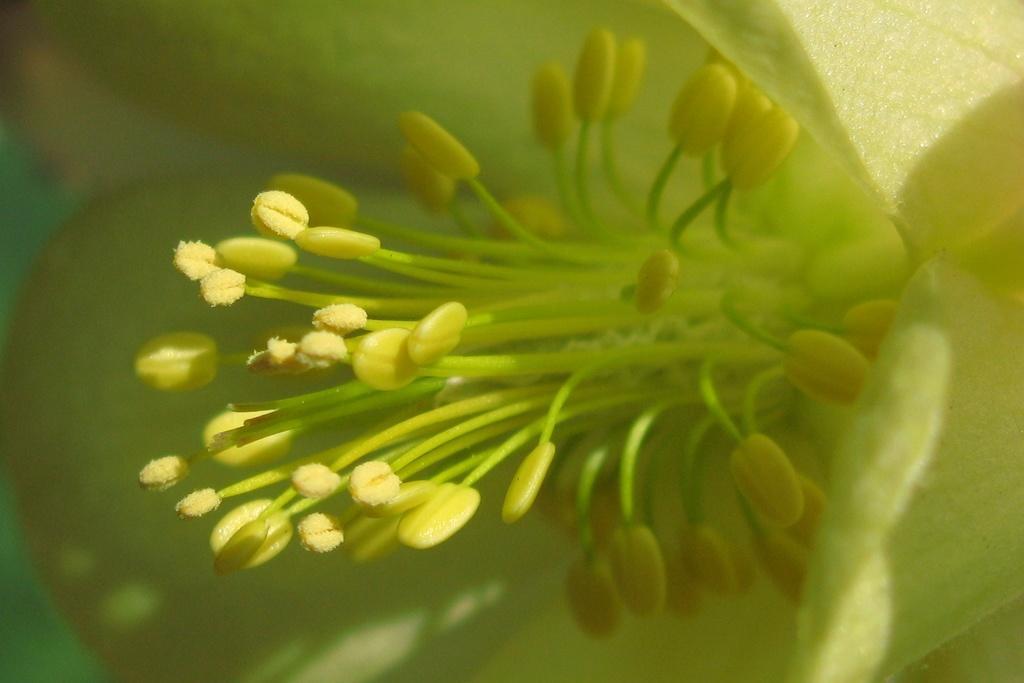In one or two sentences, can you explain what this image depicts? In this image we can see a flower. 